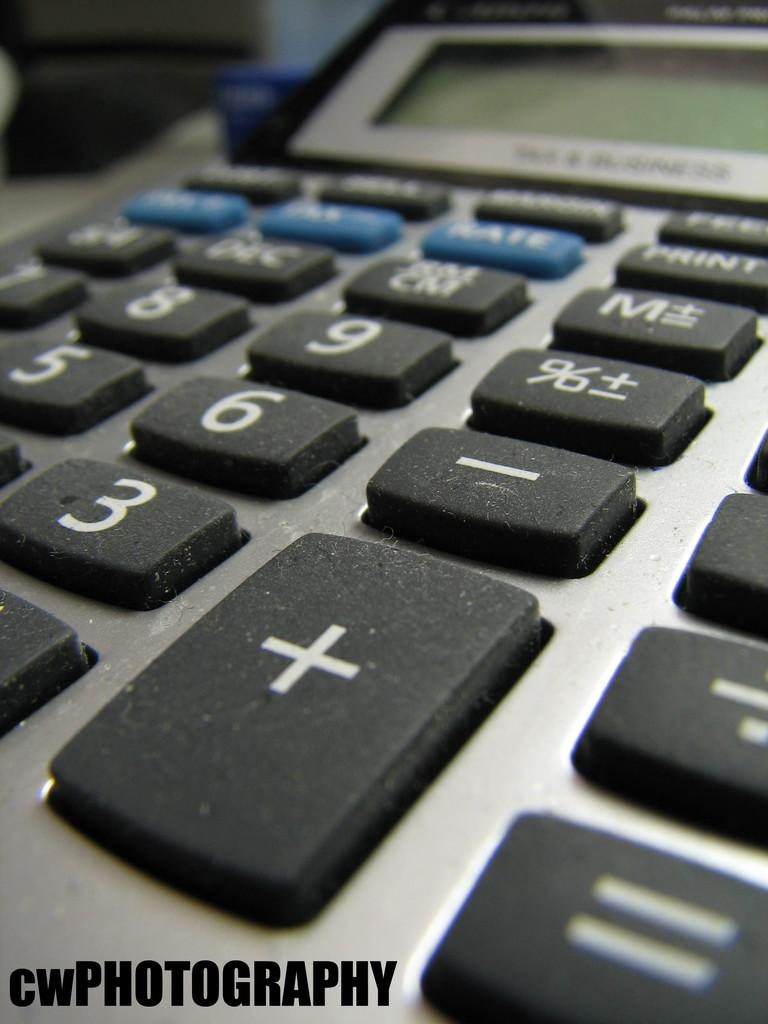<image>
Offer a succinct explanation of the picture presented. a calculator with the label CWPHOTOGRAPHY at the bottom of it 